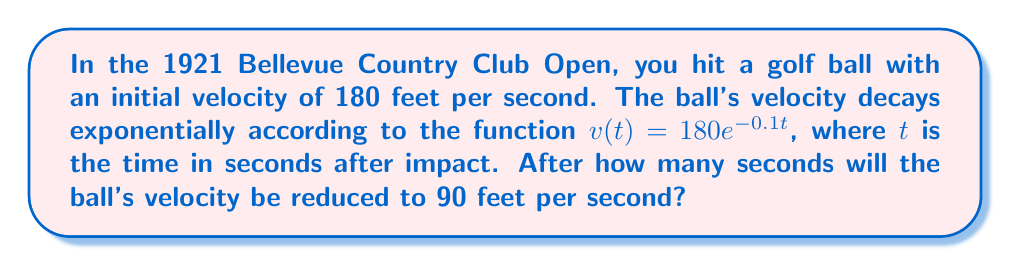Teach me how to tackle this problem. Let's approach this step-by-step:

1) We are given the exponential decay function: $v(t) = 180e^{-0.1t}$

2) We want to find $t$ when $v(t) = 90$ feet per second. So, let's set up the equation:

   $90 = 180e^{-0.1t}$

3) Divide both sides by 180:

   $\frac{1}{2} = e^{-0.1t}$

4) Take the natural logarithm of both sides:

   $\ln(\frac{1}{2}) = \ln(e^{-0.1t})$

5) Simplify the right side using the properties of logarithms:

   $\ln(\frac{1}{2}) = -0.1t$

6) Solve for $t$:

   $t = -\frac{\ln(\frac{1}{2})}{0.1}$

7) Calculate:
   
   $t = -\frac{-0.693147...}{0.1} \approx 6.93$ seconds

Therefore, it will take approximately 6.93 seconds for the ball's velocity to be reduced to 90 feet per second.
Answer: $6.93$ seconds 